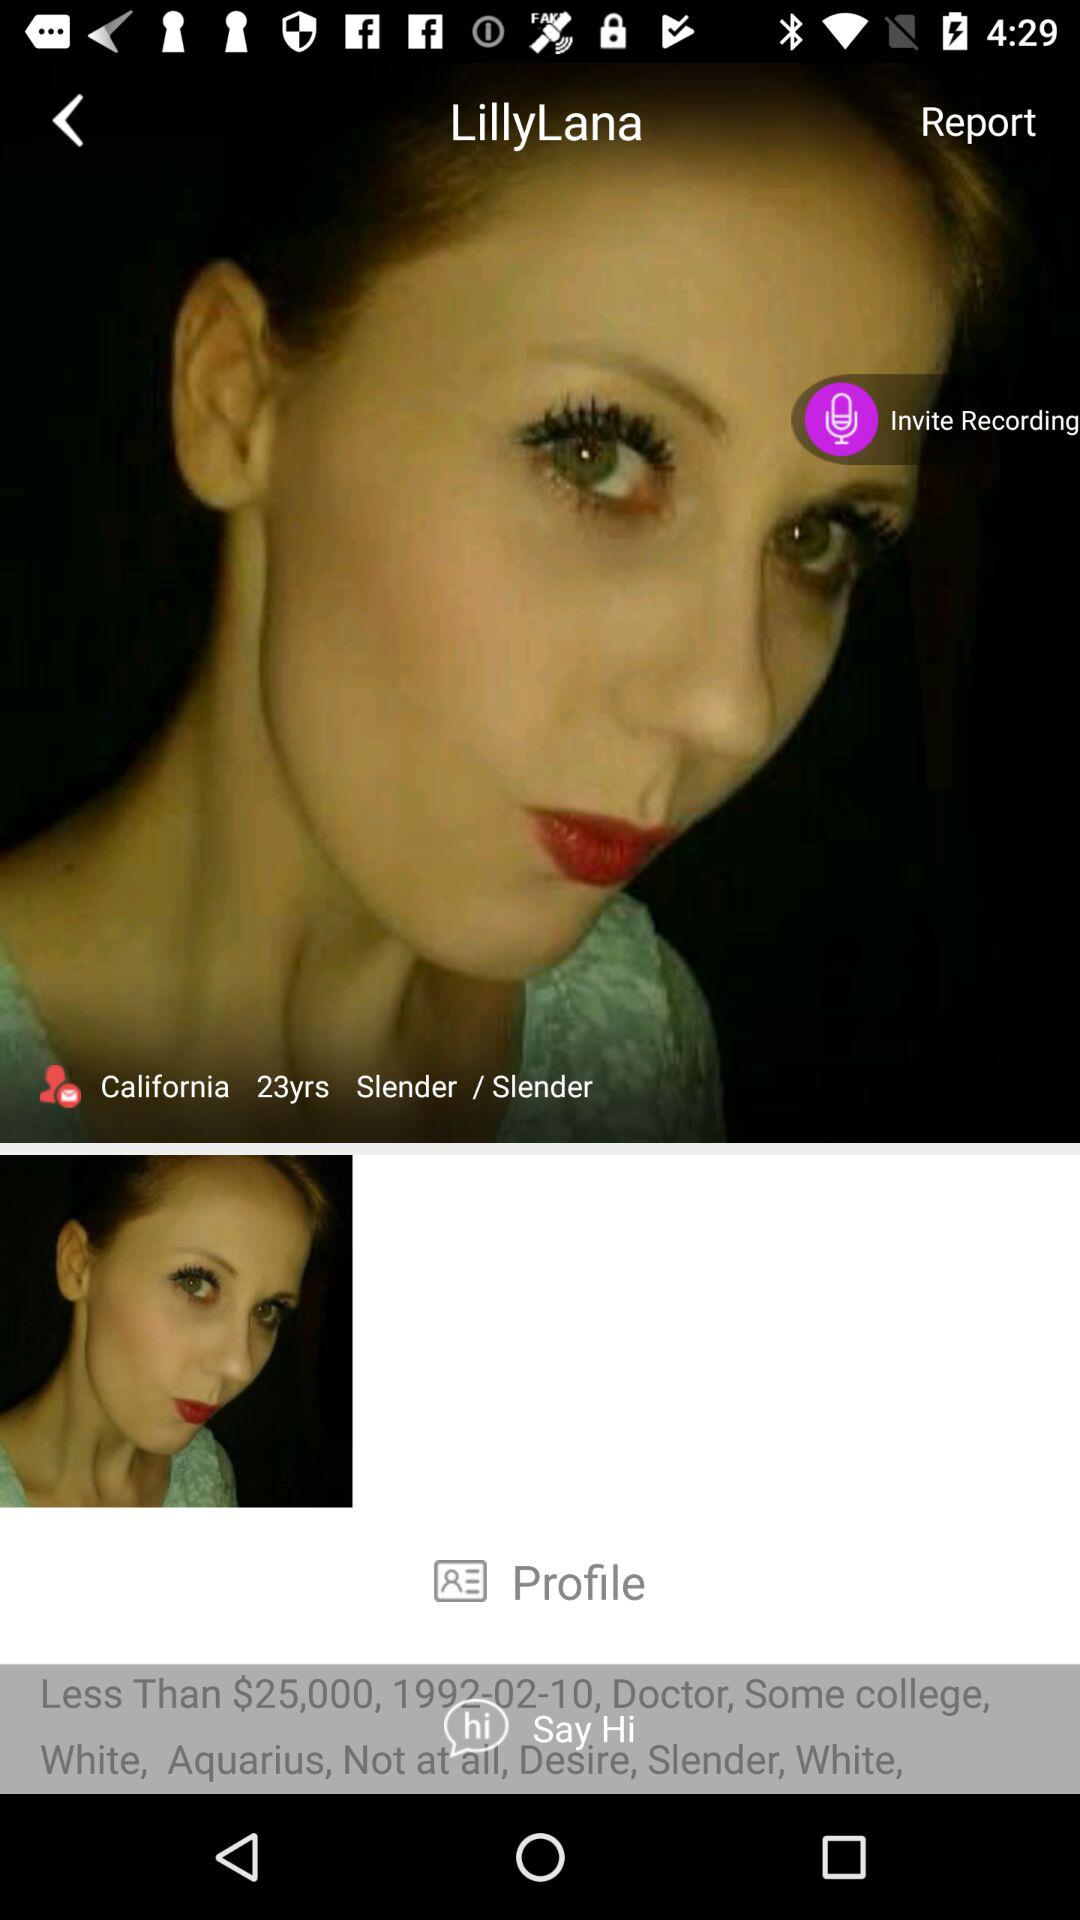Where in California does "LillyLana" live?
When the provided information is insufficient, respond with <no answer>. <no answer> 